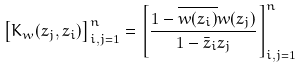<formula> <loc_0><loc_0><loc_500><loc_500>\left [ K _ { w } ( z _ { j } , z _ { i } ) \right ] _ { i , j = 1 } ^ { n } = \left [ \frac { 1 - \overline { w ( z _ { i } ) } w ( z _ { j } ) } { 1 - \bar { z } _ { i } z _ { j } } \right ] _ { i , j = 1 } ^ { n }</formula> 